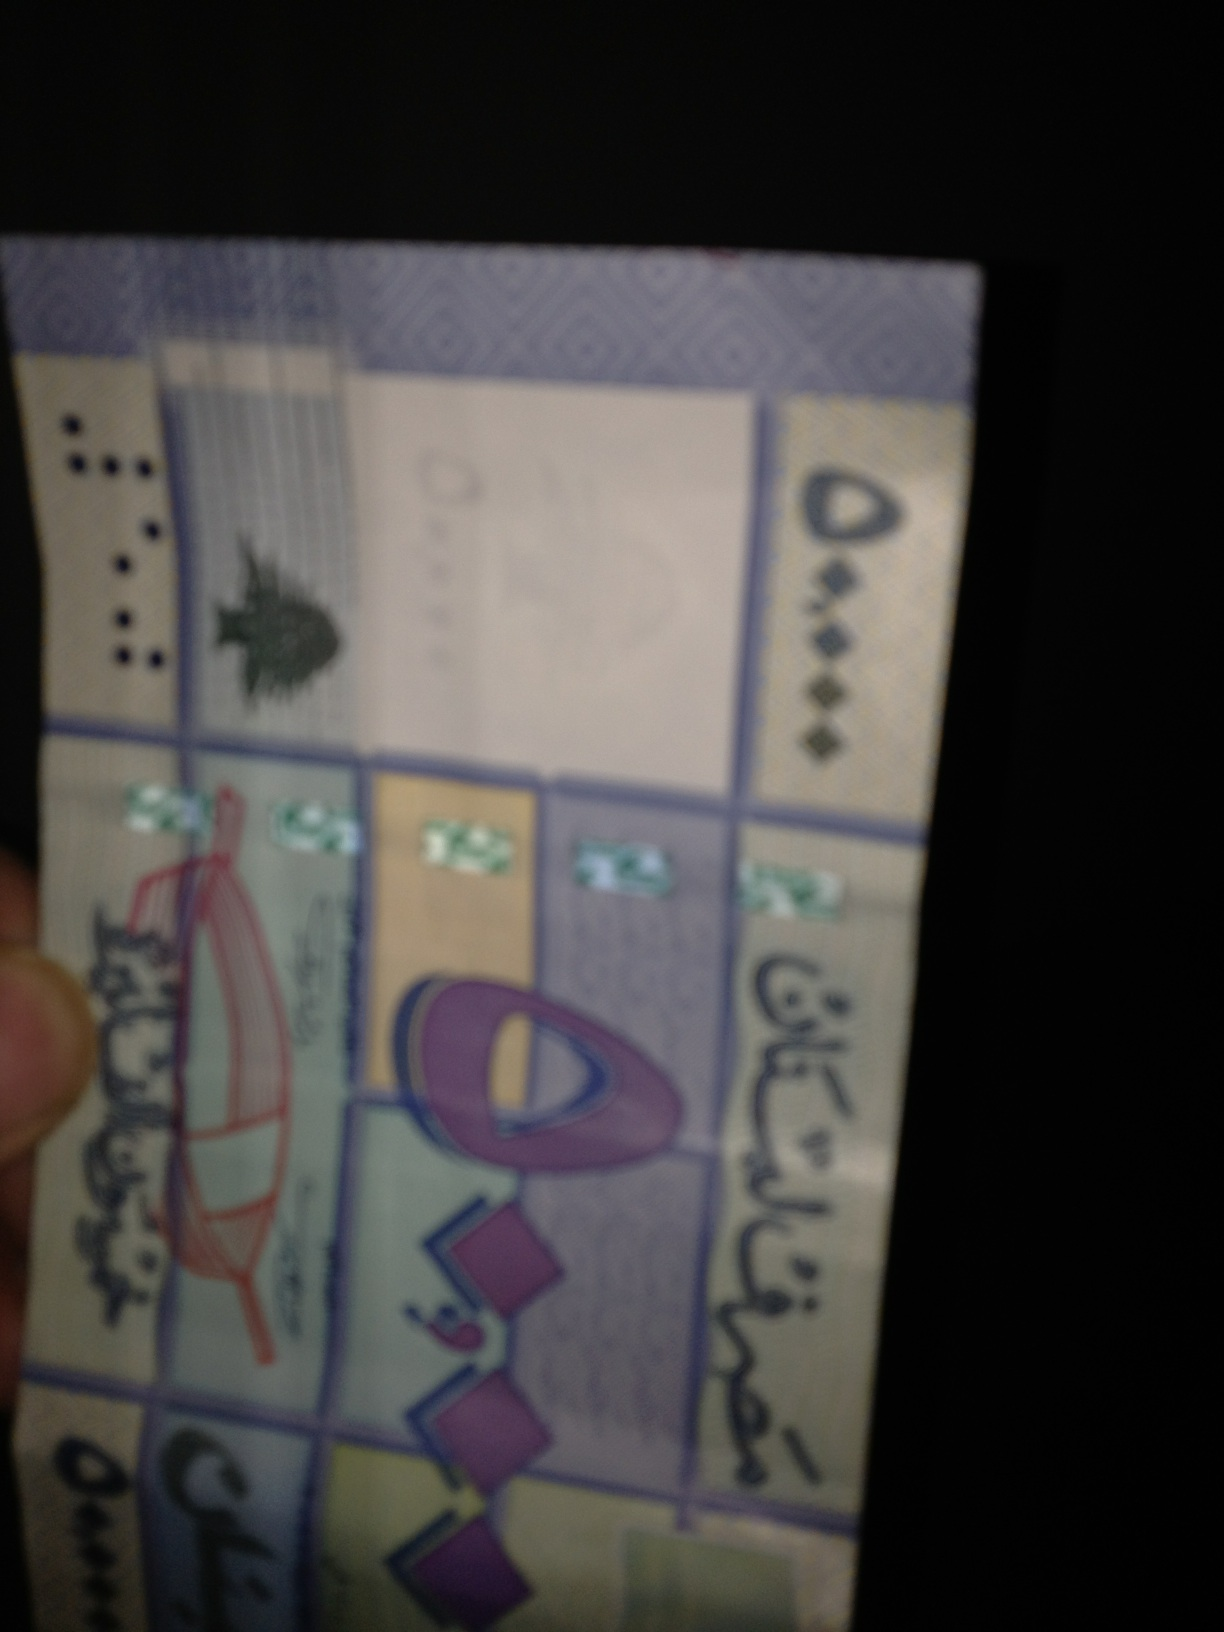Can you provide details about the currency, such as country of origin or possible value? The image is too blurred to accurately determine specific details such as country of origin or distinct denominational values of the currency shown. However, the blue tint and style could suggest these are bills from a Middle Eastern or South Asian country, often featuring ornate design elements. 